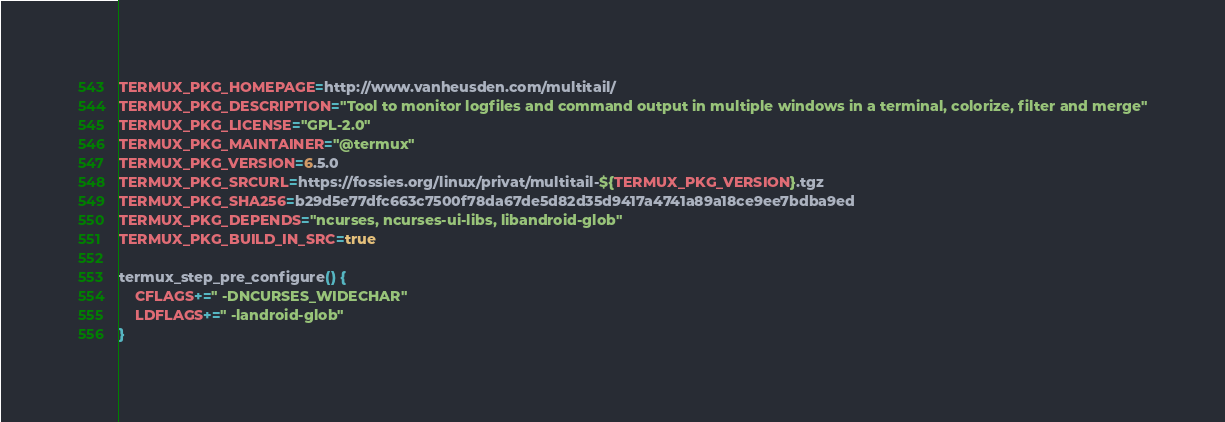<code> <loc_0><loc_0><loc_500><loc_500><_Bash_>TERMUX_PKG_HOMEPAGE=http://www.vanheusden.com/multitail/
TERMUX_PKG_DESCRIPTION="Tool to monitor logfiles and command output in multiple windows in a terminal, colorize, filter and merge"
TERMUX_PKG_LICENSE="GPL-2.0"
TERMUX_PKG_MAINTAINER="@termux"
TERMUX_PKG_VERSION=6.5.0
TERMUX_PKG_SRCURL=https://fossies.org/linux/privat/multitail-${TERMUX_PKG_VERSION}.tgz
TERMUX_PKG_SHA256=b29d5e77dfc663c7500f78da67de5d82d35d9417a4741a89a18ce9ee7bdba9ed
TERMUX_PKG_DEPENDS="ncurses, ncurses-ui-libs, libandroid-glob"
TERMUX_PKG_BUILD_IN_SRC=true

termux_step_pre_configure() {
	CFLAGS+=" -DNCURSES_WIDECHAR"
	LDFLAGS+=" -landroid-glob"
}
</code> 